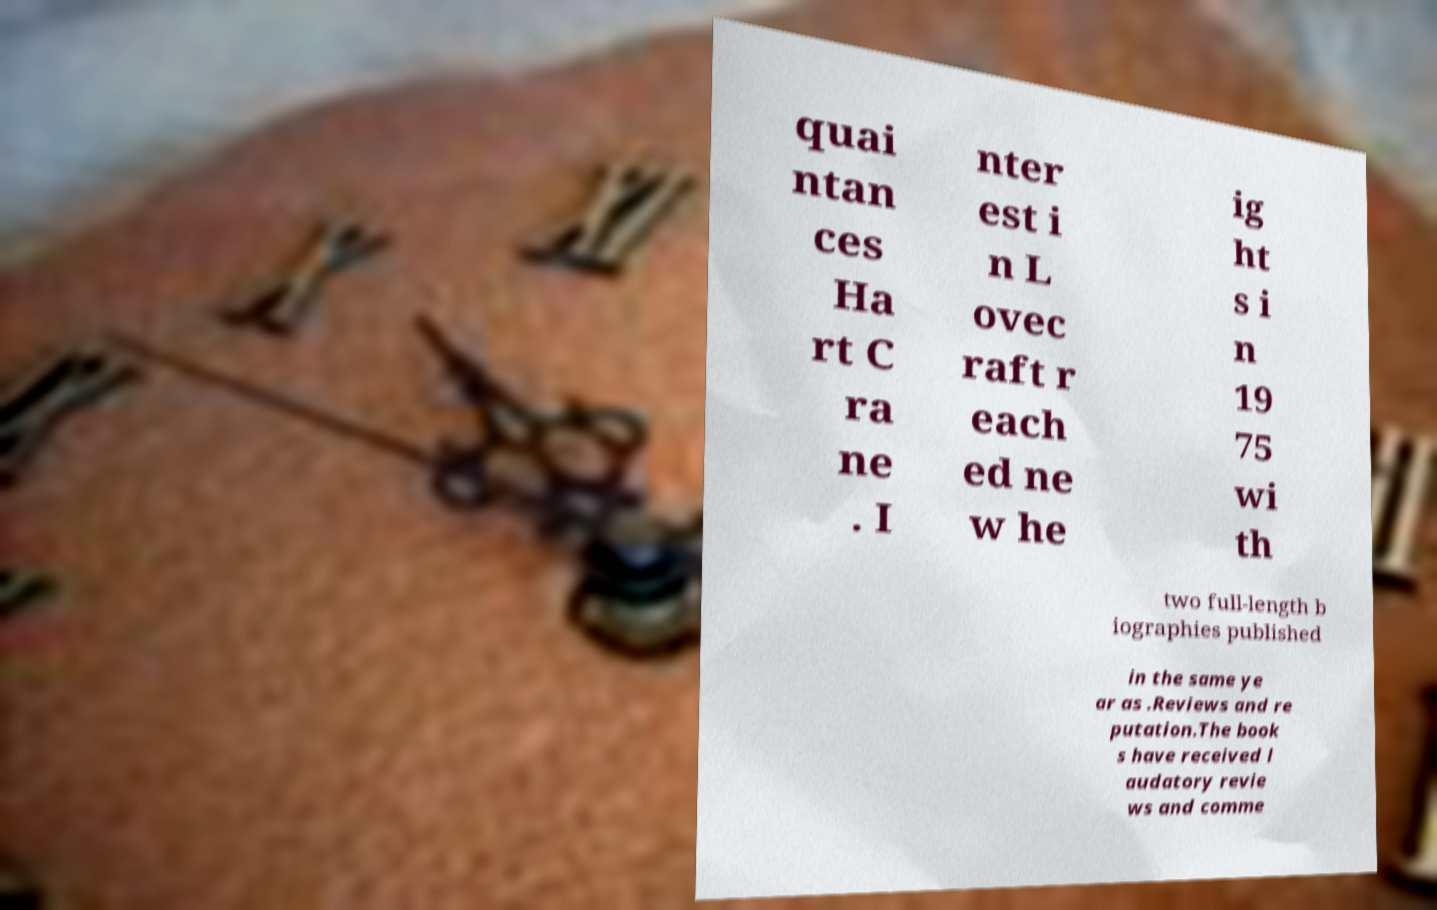Can you read and provide the text displayed in the image?This photo seems to have some interesting text. Can you extract and type it out for me? quai ntan ces Ha rt C ra ne . I nter est i n L ovec raft r each ed ne w he ig ht s i n 19 75 wi th two full-length b iographies published in the same ye ar as .Reviews and re putation.The book s have received l audatory revie ws and comme 